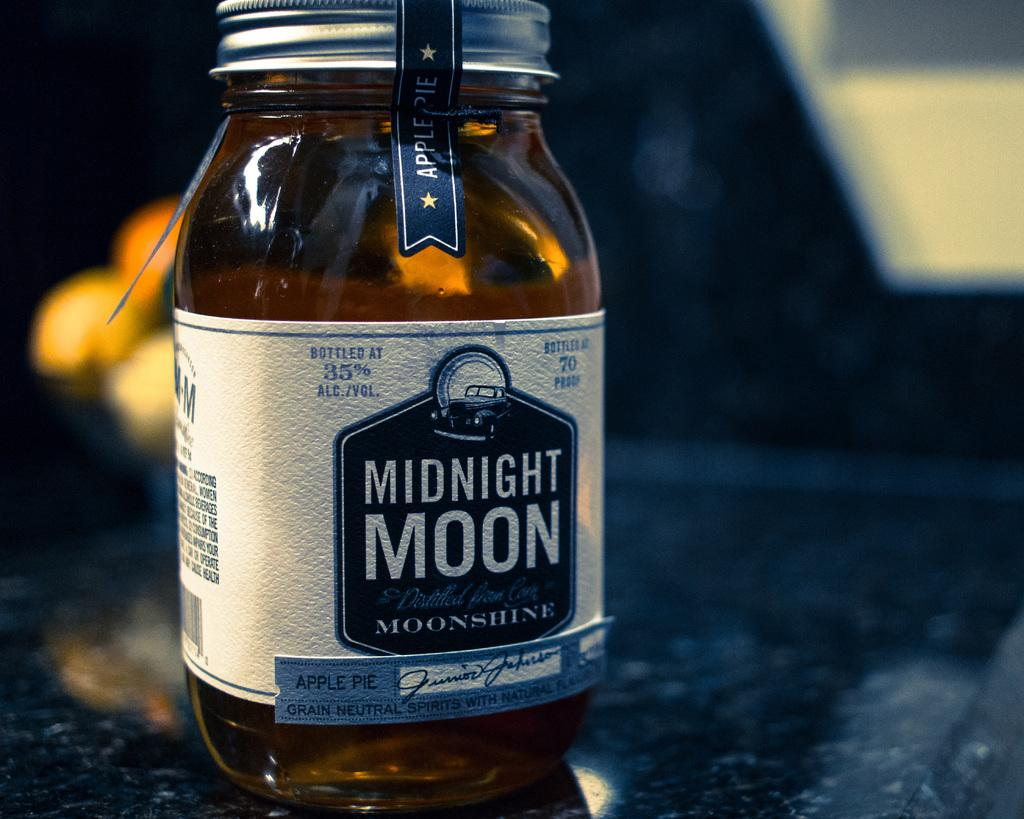<image>
Write a terse but informative summary of the picture. Midnight Moonshine that has the flavor of Apple Pie wiith 35% Alcohol by Volume. 